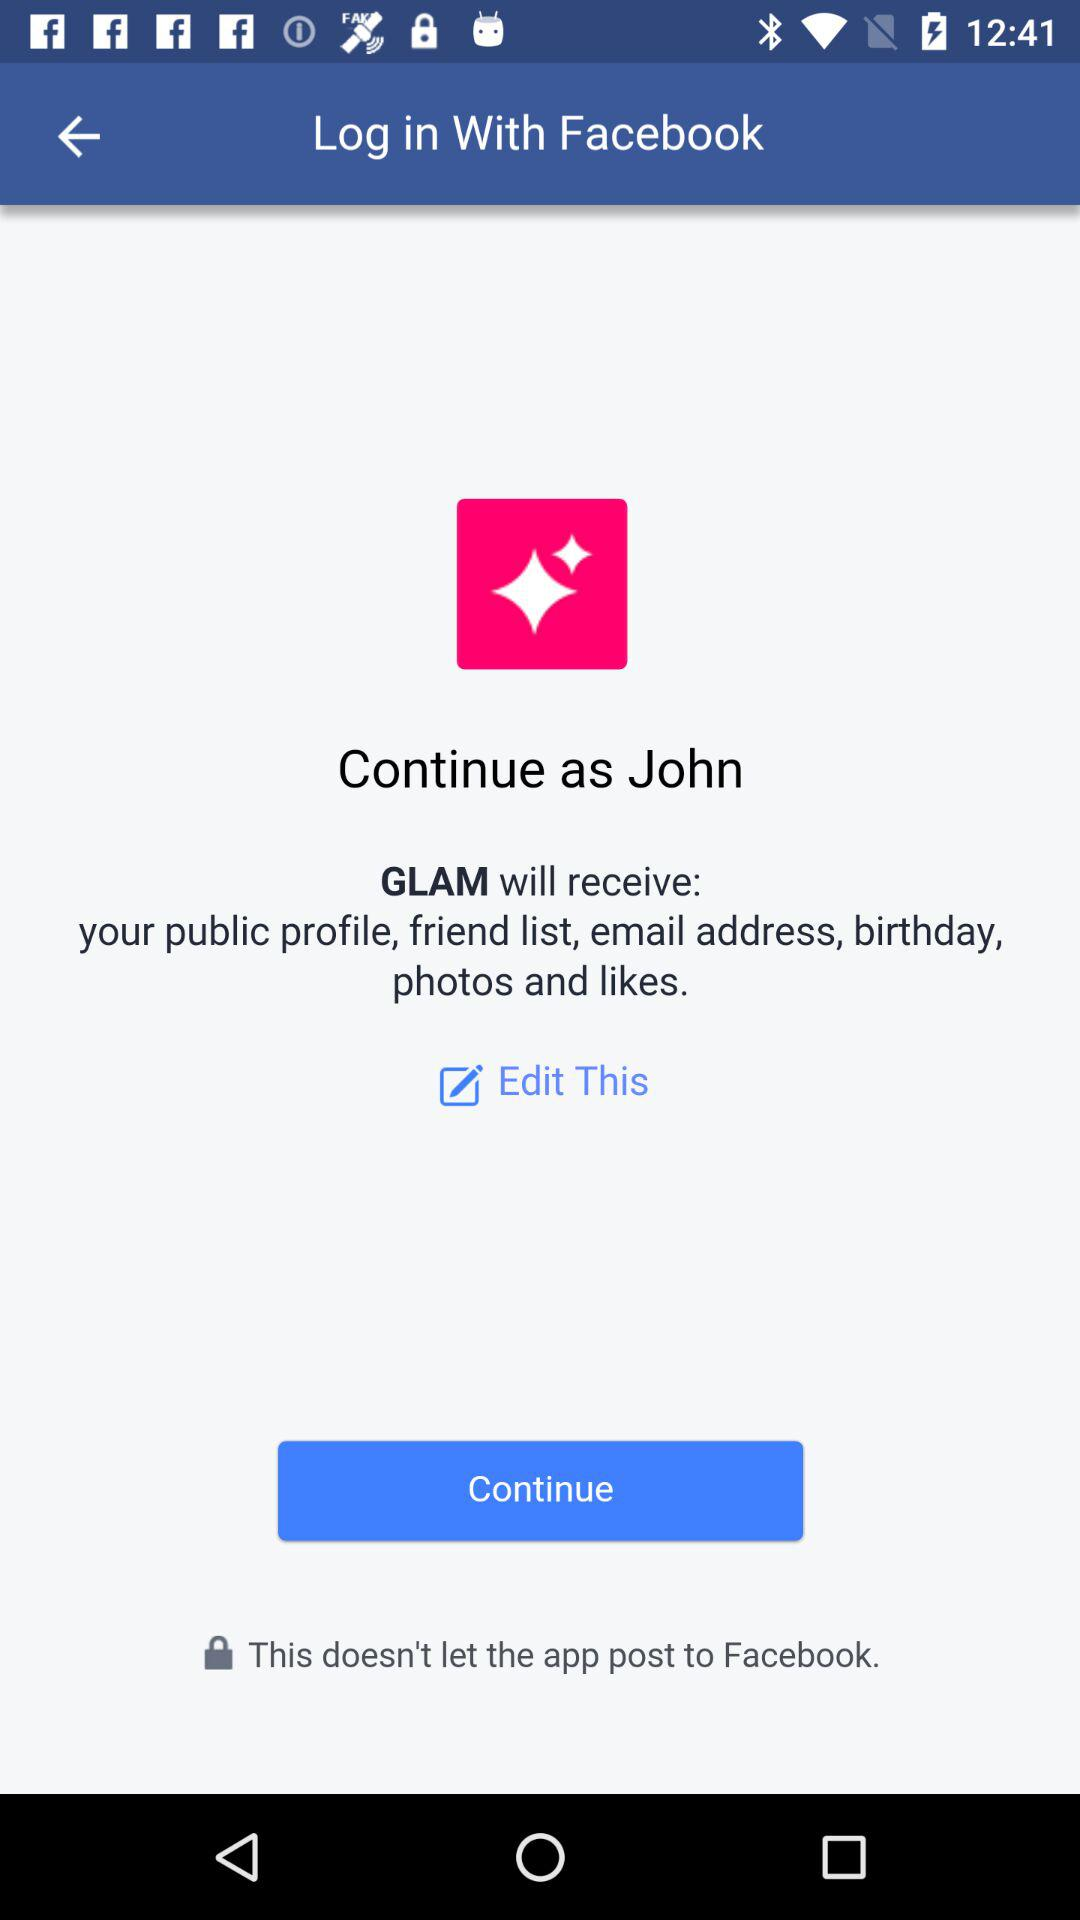What is the username? The username is "John". 